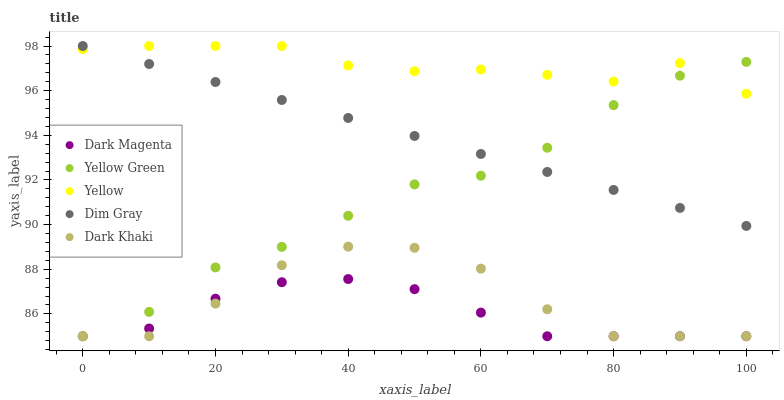Does Dark Magenta have the minimum area under the curve?
Answer yes or no. Yes. Does Yellow have the maximum area under the curve?
Answer yes or no. Yes. Does Dim Gray have the minimum area under the curve?
Answer yes or no. No. Does Dim Gray have the maximum area under the curve?
Answer yes or no. No. Is Dim Gray the smoothest?
Answer yes or no. Yes. Is Dark Khaki the roughest?
Answer yes or no. Yes. Is Dark Magenta the smoothest?
Answer yes or no. No. Is Dark Magenta the roughest?
Answer yes or no. No. Does Dark Khaki have the lowest value?
Answer yes or no. Yes. Does Dim Gray have the lowest value?
Answer yes or no. No. Does Yellow have the highest value?
Answer yes or no. Yes. Does Dark Magenta have the highest value?
Answer yes or no. No. Is Dark Khaki less than Yellow?
Answer yes or no. Yes. Is Dim Gray greater than Dark Magenta?
Answer yes or no. Yes. Does Yellow intersect Dim Gray?
Answer yes or no. Yes. Is Yellow less than Dim Gray?
Answer yes or no. No. Is Yellow greater than Dim Gray?
Answer yes or no. No. Does Dark Khaki intersect Yellow?
Answer yes or no. No. 